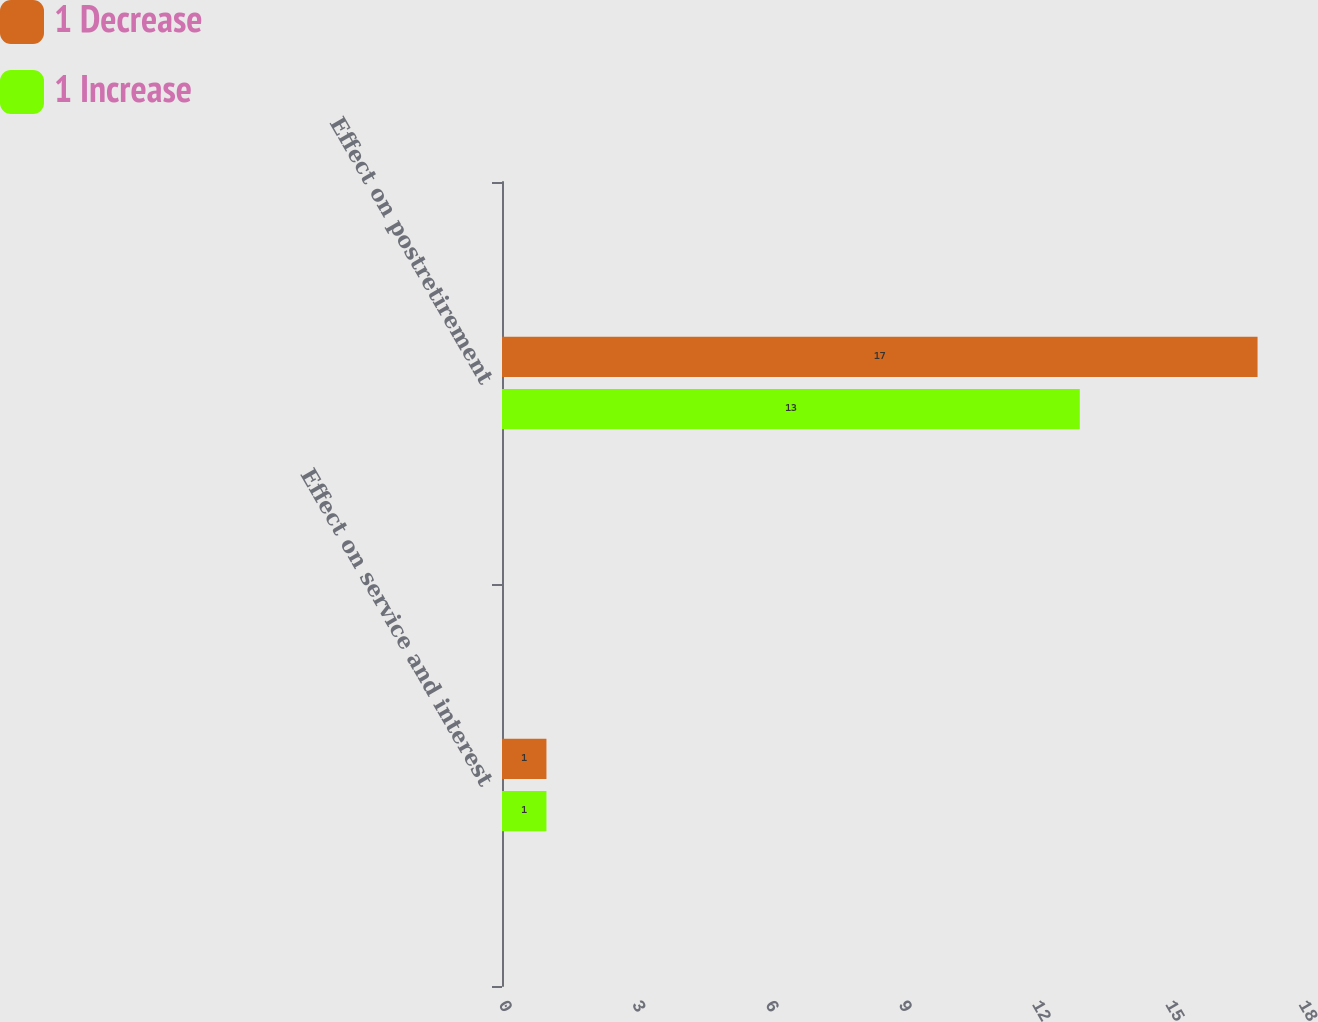Convert chart to OTSL. <chart><loc_0><loc_0><loc_500><loc_500><stacked_bar_chart><ecel><fcel>Effect on service and interest<fcel>Effect on postretirement<nl><fcel>1 Decrease<fcel>1<fcel>17<nl><fcel>1 Increase<fcel>1<fcel>13<nl></chart> 